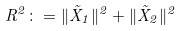<formula> <loc_0><loc_0><loc_500><loc_500>R ^ { 2 } \colon = \| \vec { X } _ { 1 } \| ^ { 2 } + \| \vec { X } _ { 2 } \| ^ { 2 }</formula> 